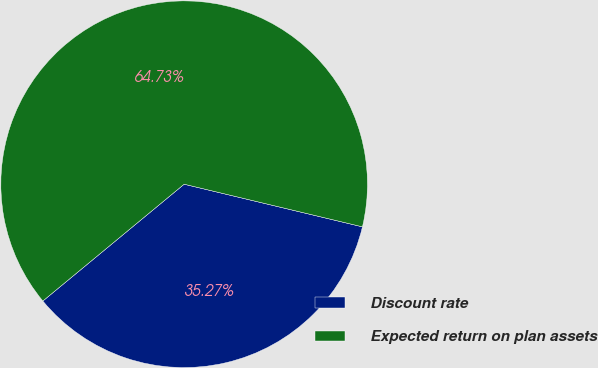Convert chart to OTSL. <chart><loc_0><loc_0><loc_500><loc_500><pie_chart><fcel>Discount rate<fcel>Expected return on plan assets<nl><fcel>35.27%<fcel>64.73%<nl></chart> 